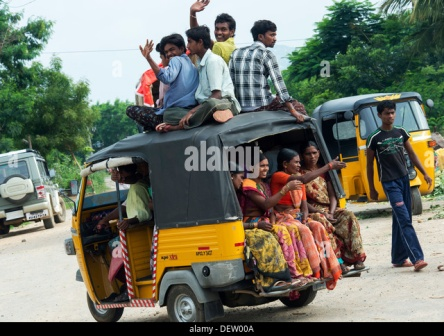Can you describe a realistic short scenario involving the people from the image? The group had just wrapped up a long day of work at the local market. Exhausted but happy, they decided to share a rickshaw ride home. Opting to make the most of their trip, some chose to sit on the roof, transforming a mundane commute into a spontaneous celebration. They laughed and chatted, exchanging stories from their busy day, enjoying the cool breeze of the early evening as they journeyed home together. 